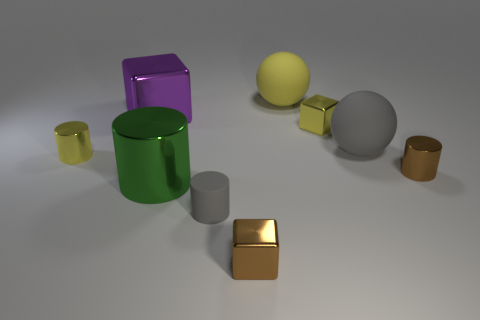What color is the other object that is the same shape as the large gray matte object?
Provide a short and direct response. Yellow. What number of things are shiny cubes or shiny balls?
Offer a terse response. 3. There is a small yellow metal object that is to the right of the tiny rubber object; does it have the same shape as the yellow matte object that is on the right side of the purple block?
Make the answer very short. No. What is the shape of the gray rubber thing that is in front of the green thing?
Your answer should be compact. Cylinder. Are there an equal number of large metal objects that are on the left side of the purple shiny object and tiny brown metallic blocks that are on the right side of the brown metal block?
Provide a short and direct response. Yes. What number of things are large spheres or matte things in front of the brown metal cylinder?
Your answer should be very brief. 3. What is the shape of the small metal object that is to the right of the yellow matte thing and in front of the yellow shiny cylinder?
Ensure brevity in your answer.  Cylinder. There is a small brown thing that is on the left side of the matte object right of the small yellow shiny cube; what is it made of?
Ensure brevity in your answer.  Metal. Do the object behind the purple metal object and the small yellow cube have the same material?
Offer a very short reply. No. There is a brown metallic thing in front of the tiny matte thing; what is its size?
Your answer should be compact. Small. 